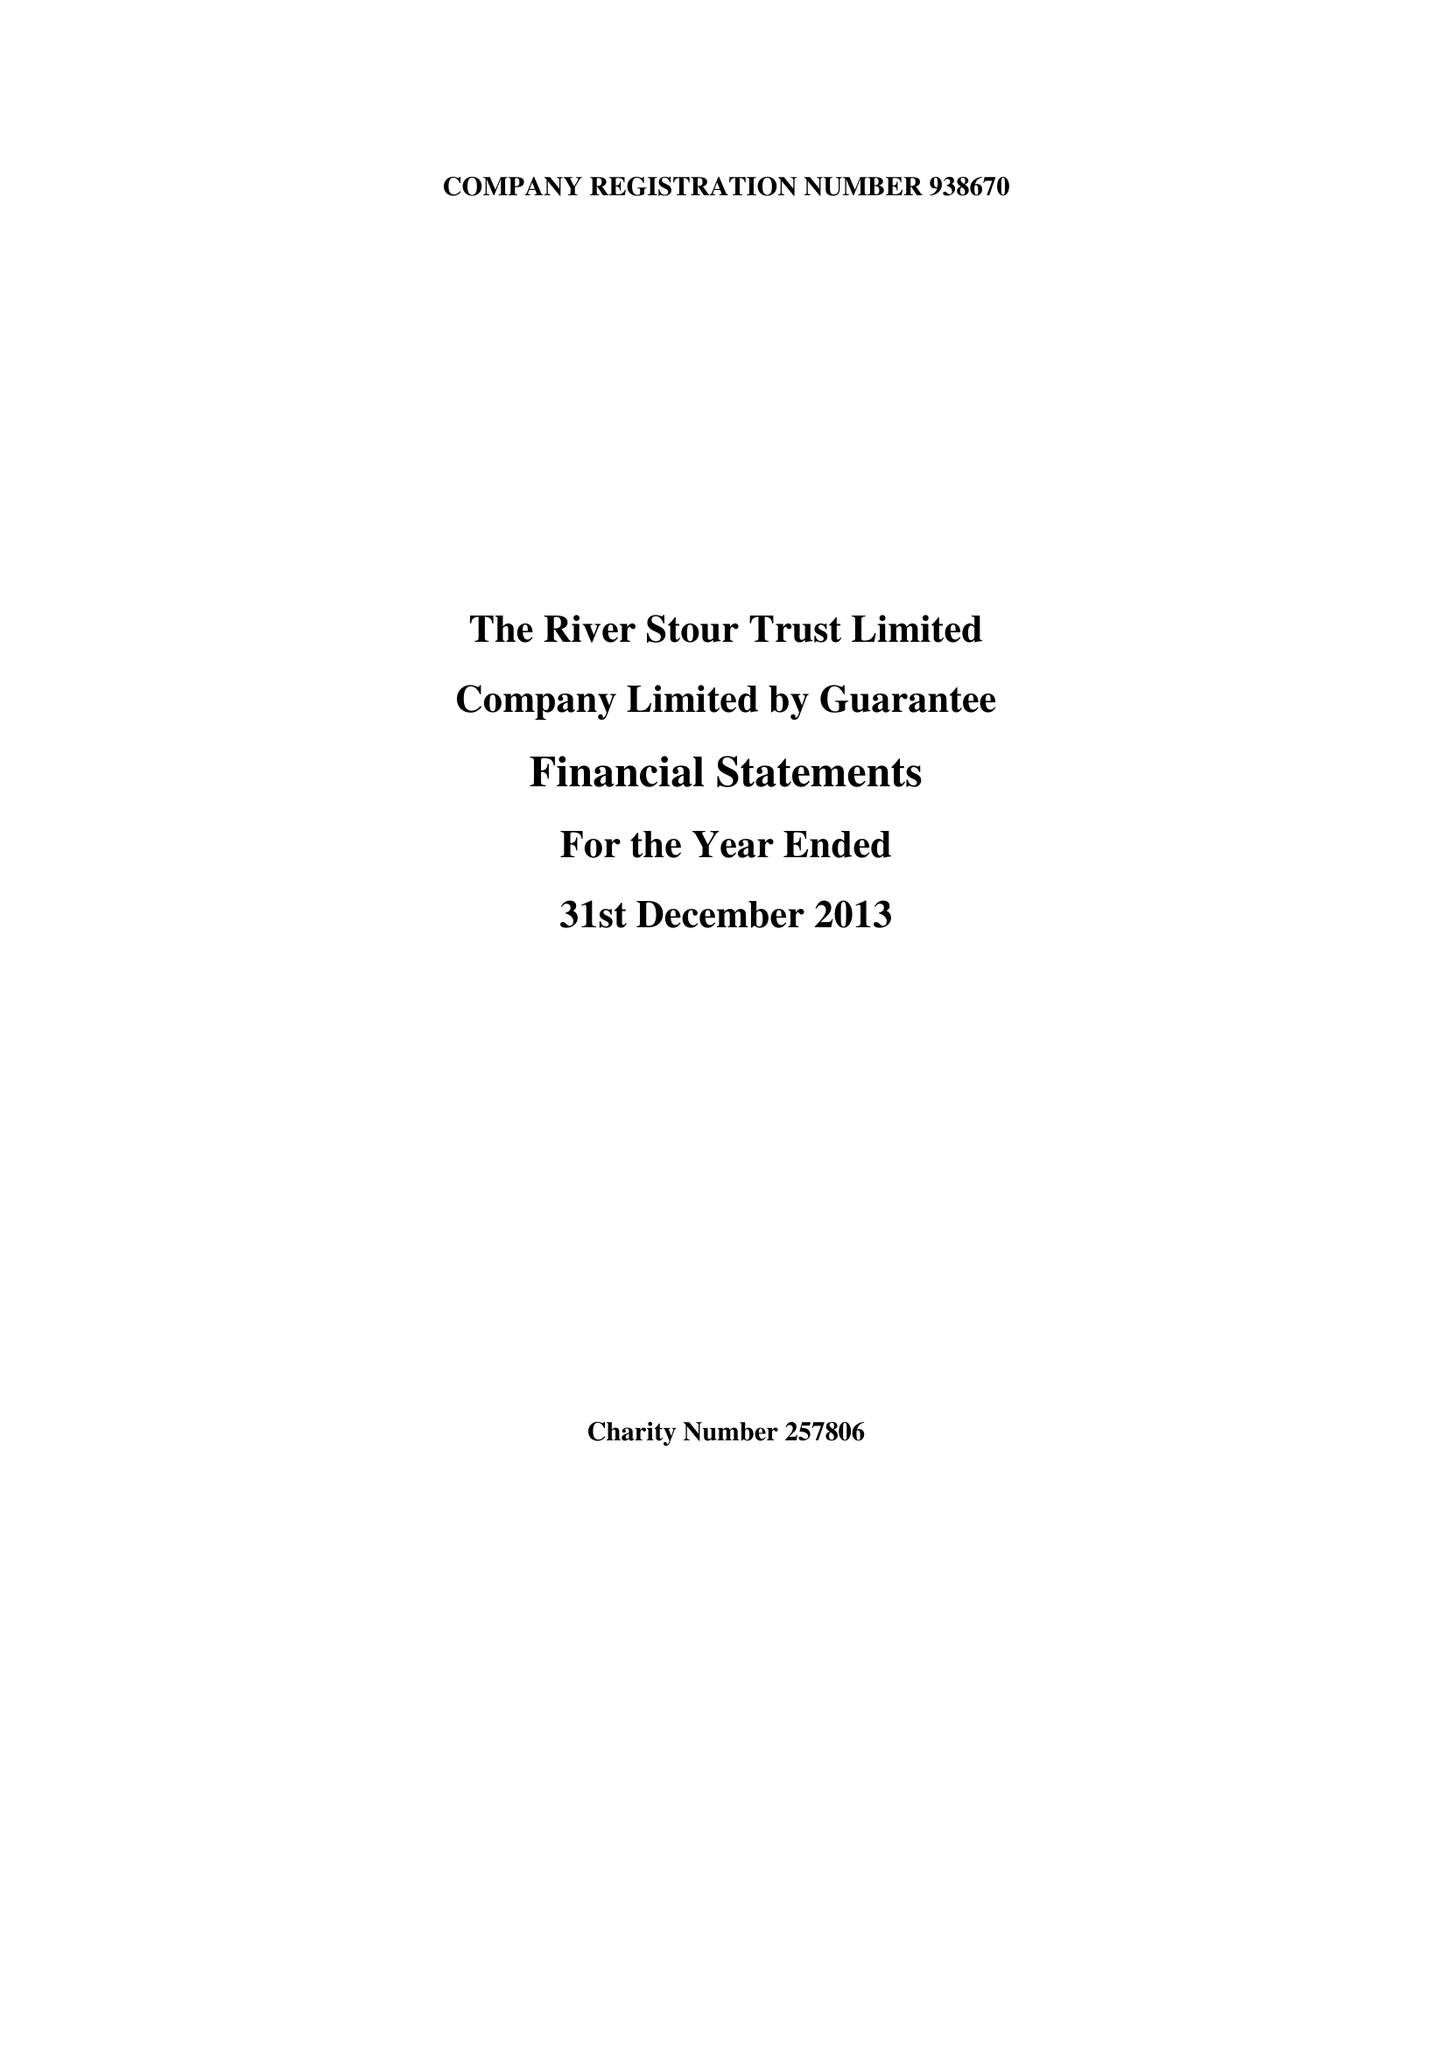What is the value for the report_date?
Answer the question using a single word or phrase. 2013-12-31 